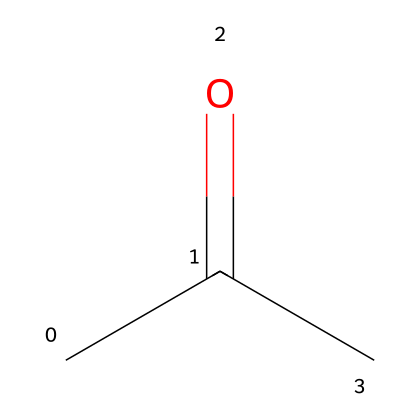What is the common name of this chemical? The SMILES representation indicates a compound with an acetyl group followed by a methyl group, which is commonly known as acetone.
Answer: acetone How many carbon atoms are in this compound? By analyzing the SMILES, there are three carbon atoms present: two in the methyl group and one in the carbonyl group (C=O).
Answer: three What functional group is present in this structure? The chemical structure shows a carbonyl group (C=O), which is indicative of a ketone. Therefore, the functional group in acetone is a ketone.
Answer: ketone How many hydrogen atoms are in this compound? The SMILES representation indicates that there are six hydrogen atoms bonded to the three carbon atoms considering the standard valency and connectivity.
Answer: six What is the total number of bonds in this structure? There are three C-H bonds, one C=O double bond, and one C-C bond, making a total of five bonds in the molecule.
Answer: five Is this compound saturated or unsaturated? Saturated compounds contain single bonds only. Since acetone has a carbonyl double bond and all other bonds are single, it is considered unsaturated.
Answer: unsaturated 